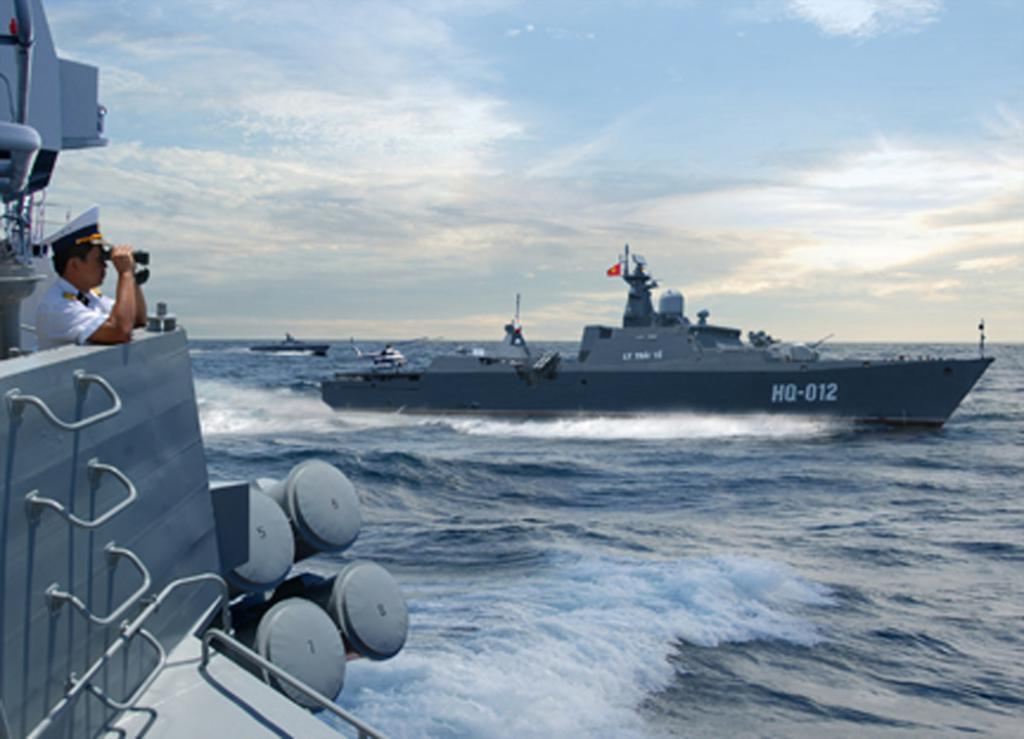What is the main feature of the image? The main feature of the image is a water surface. What can be seen on the water surface? There are ships on the water surface. Where is the man located in the image? The man is standing on the left side of the image. What is the man holding in his hands? The man is holding binoculars in his hands. What type of jelly can be seen floating on the water surface in the image? There is no jelly present on the water surface in the image. What is the man's position in relation to the ships? The man's position in relation to the ships is not mentioned in the facts, so we cannot determine his position relative to the ships. 